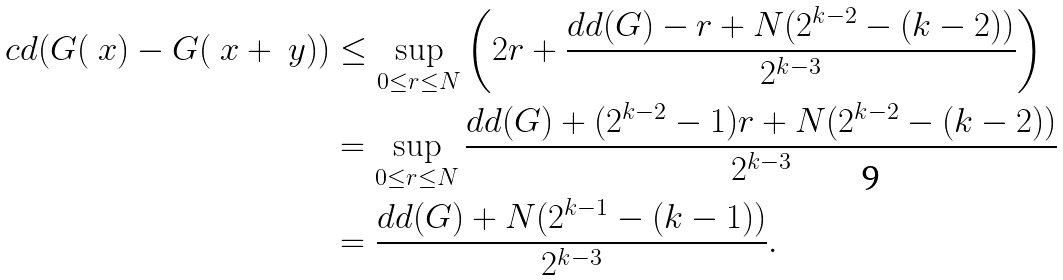Convert formula to latex. <formula><loc_0><loc_0><loc_500><loc_500>c d ( G ( \ x ) - G ( \ x + \ y ) ) & \leq \sup _ { 0 \leq r \leq N } \left ( 2 r + \frac { d d ( G ) - r + N ( 2 ^ { k - 2 } - ( k - 2 ) ) } { 2 ^ { k - 3 } } \right ) \\ & = \sup _ { 0 \leq r \leq N } \frac { d d ( G ) + ( 2 ^ { k - 2 } - 1 ) r + N ( 2 ^ { k - 2 } - ( k - 2 ) ) } { 2 ^ { k - 3 } } \\ & = \frac { d d ( G ) + N ( 2 ^ { k - 1 } - ( k - 1 ) ) } { 2 ^ { k - 3 } } .</formula> 